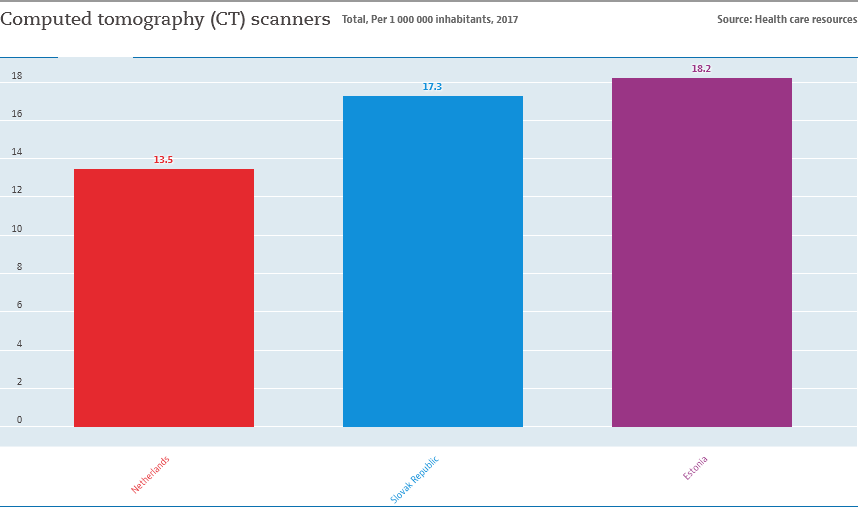List a handful of essential elements in this visual. According to the data, Estonia has the highest number of computed tomography (CT) scanners per capita when compared to other countries in the European Union. The ratio of the Netherlands and Slovak Republic is 0.78035... 